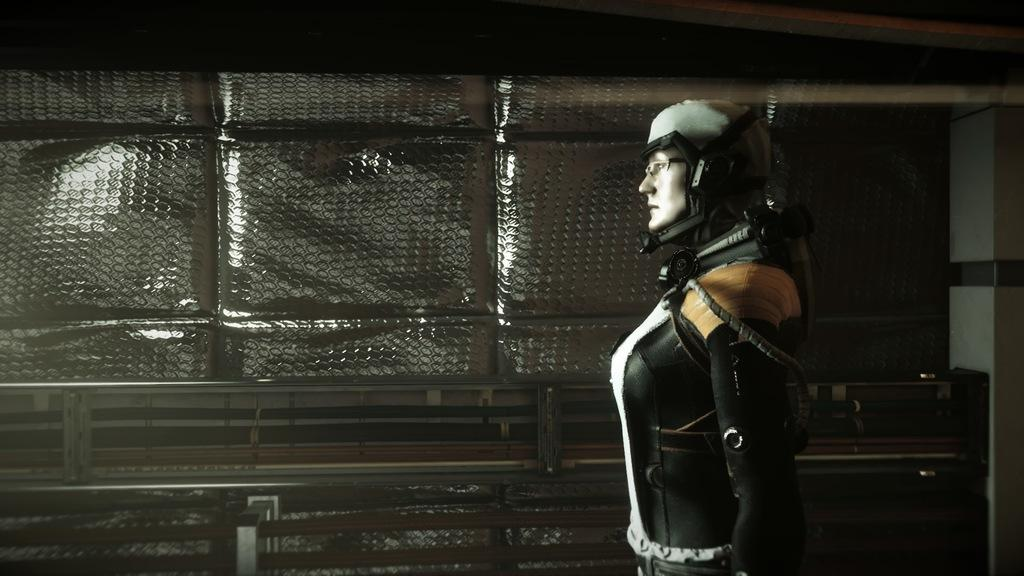What type of image is being described? The image is animated. Can you describe the person in the image? There is a person in the image. What kind of objects can be seen in the image? There are metal poles and a wall with objects in the image. What type of pot is the person holding in the image? There is no pot present in the image. Can you describe the grandfather's knee in the image? There is no grandfather or mention of a knee in the image. 